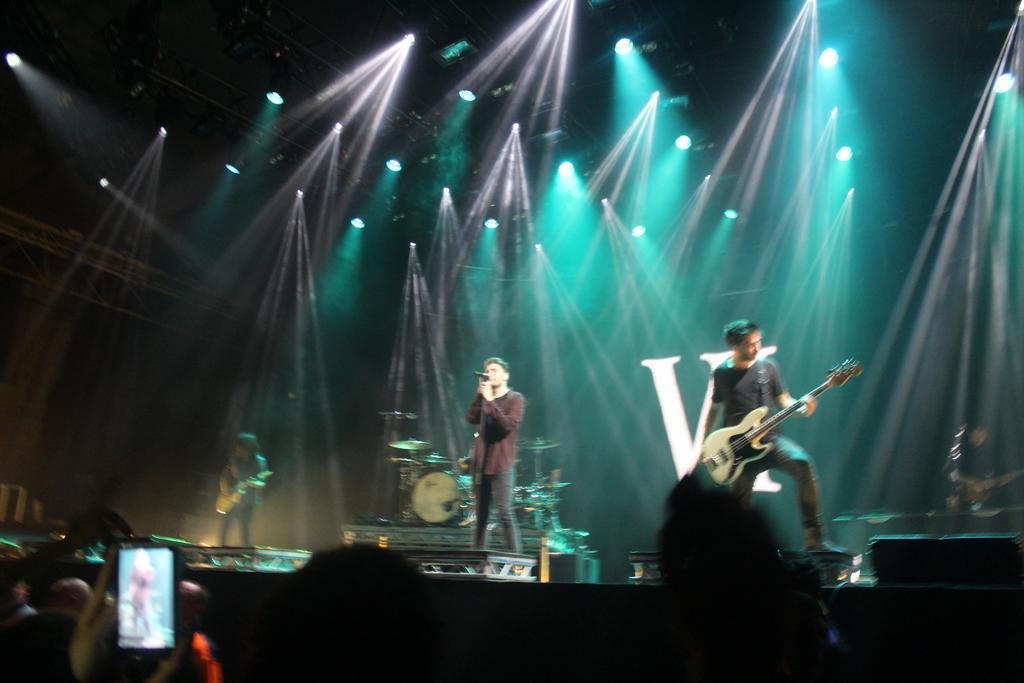Describe this image in one or two sentences. In this image I can see a stage and on it I can see four persons are standing. I can also see three of them are holding guitars and one is holding a mic. In the front I can see number of people and I can see one of them is holding a phone. In the background I can see number of lights and a drum set. I can also see something is written in the background. 